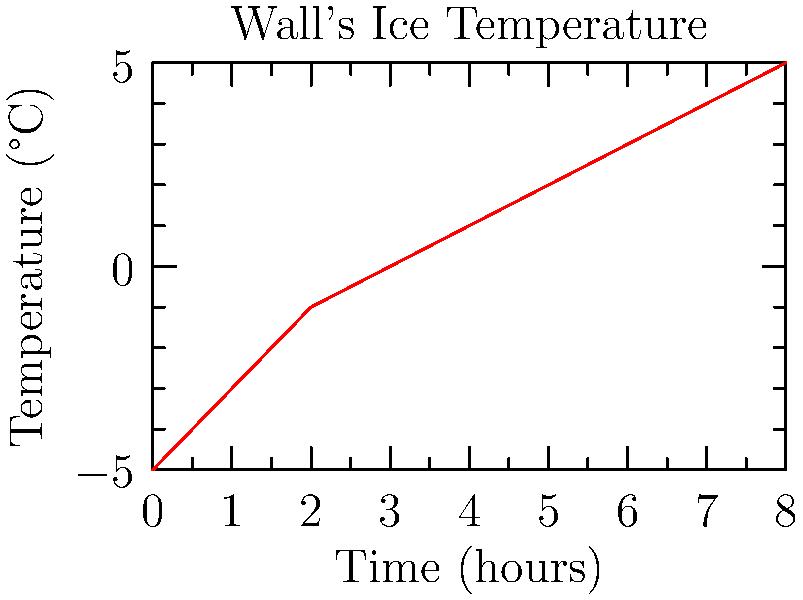The graph shows the temperature variation of the Wall's magical ice over time. If the energy required to maintain the ice at 0°C is proportional to the area between the temperature curve and the 0°C line, calculate the relative energy efficiency of the Wall's magical preservation system in the first 4 hours compared to the last 4 hours. Express your answer as a percentage. To solve this problem, we need to follow these steps:

1. Calculate the area between the curve and the 0°C line for the first 4 hours (0-4h).
2. Calculate the area between the curve and the 0°C line for the last 4 hours (4-8h).
3. Compare these areas to determine the relative energy efficiency.

Step 1: Area for the first 4 hours
- We can approximate this area using the trapezoidal rule:
  Area ≈ $\frac{1}{2}(4)(-5 + (-3) + (-1) + 0) = -9$ °C·h

Step 2: Area for the last 4 hours
- Similarly, using the trapezoidal rule:
  Area ≈ $\frac{1}{2}(4)(0 + 1 + 2 + 3 + 4) = 10$ °C·h

Step 3: Relative energy efficiency
- The smaller area represents better energy efficiency (less energy needed to maintain 0°C).
- Relative efficiency = (Smaller area / Larger area) × 100%
- $\frac{9}{10} \times 100\% = 90\%$

Therefore, the Wall's magical ice preservation system is 90% as efficient in the first 4 hours compared to the last 4 hours.
Answer: 90% 